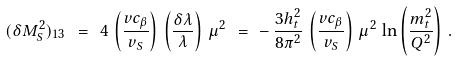<formula> <loc_0><loc_0><loc_500><loc_500>( \delta M ^ { 2 } _ { S } ) _ { 1 3 } \ = \ 4 \, \left ( \frac { v c _ { \beta } } { v _ { S } } \right ) \, \left ( \frac { \delta \lambda } { \lambda } \right ) \, \mu ^ { 2 } \ = \ - \, \frac { 3 h ^ { 2 } _ { t } } { 8 \pi ^ { 2 } } \, \left ( \frac { v c _ { \beta } } { v _ { S } } \right ) \, \mu ^ { 2 } \, \ln \left ( \frac { m ^ { 2 } _ { t } } { Q ^ { 2 } } \right ) \, .</formula> 